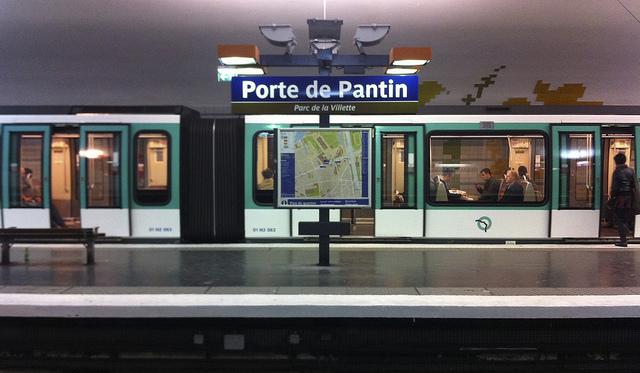Are there lights shining up?
Be succinct. Yes. Is this a train station in France?
Be succinct. Yes. What color are the lines on the train platform?
Be succinct. White. 